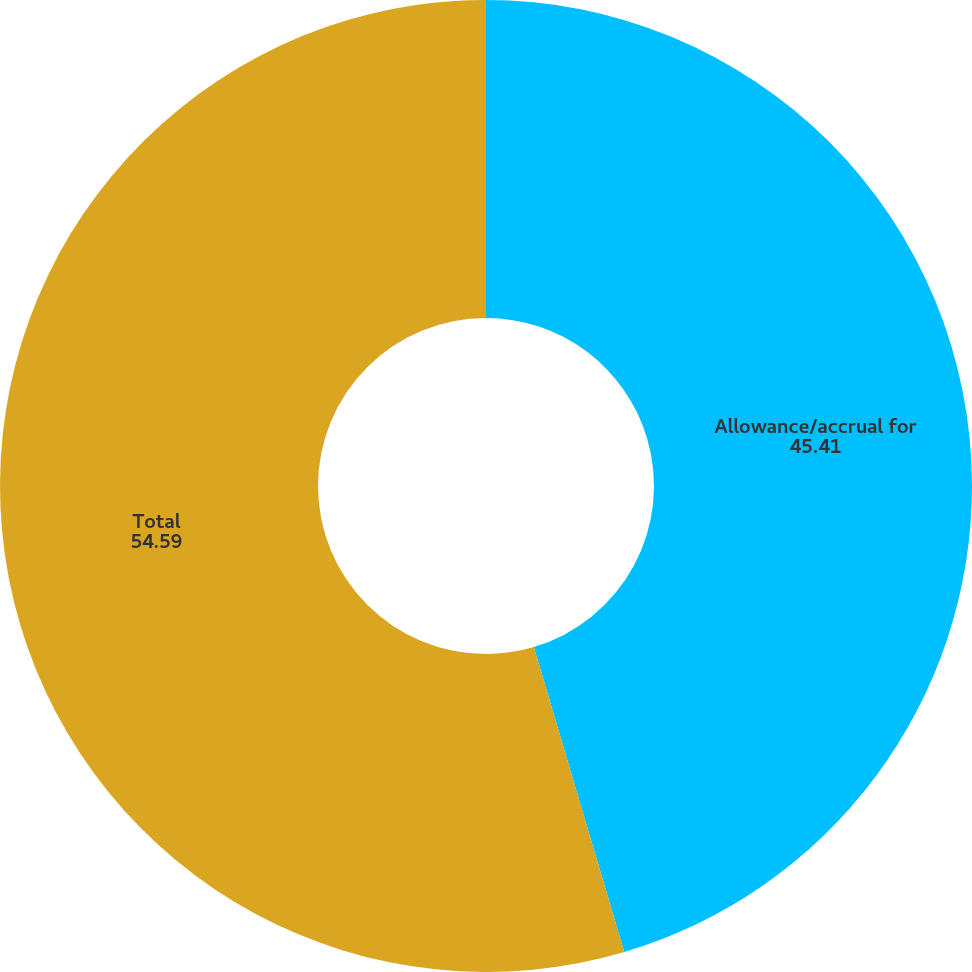Convert chart to OTSL. <chart><loc_0><loc_0><loc_500><loc_500><pie_chart><fcel>Allowance/accrual for<fcel>Total<nl><fcel>45.41%<fcel>54.59%<nl></chart> 